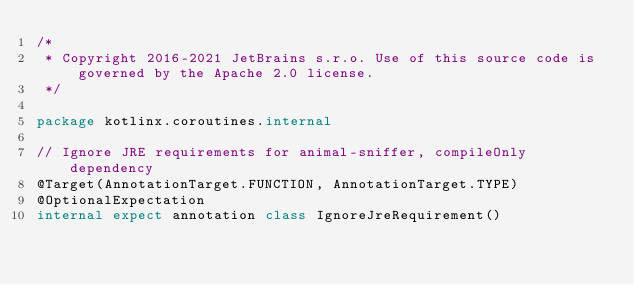Convert code to text. <code><loc_0><loc_0><loc_500><loc_500><_Kotlin_>/*
 * Copyright 2016-2021 JetBrains s.r.o. Use of this source code is governed by the Apache 2.0 license.
 */

package kotlinx.coroutines.internal

// Ignore JRE requirements for animal-sniffer, compileOnly dependency
@Target(AnnotationTarget.FUNCTION, AnnotationTarget.TYPE)
@OptionalExpectation
internal expect annotation class IgnoreJreRequirement()
</code> 